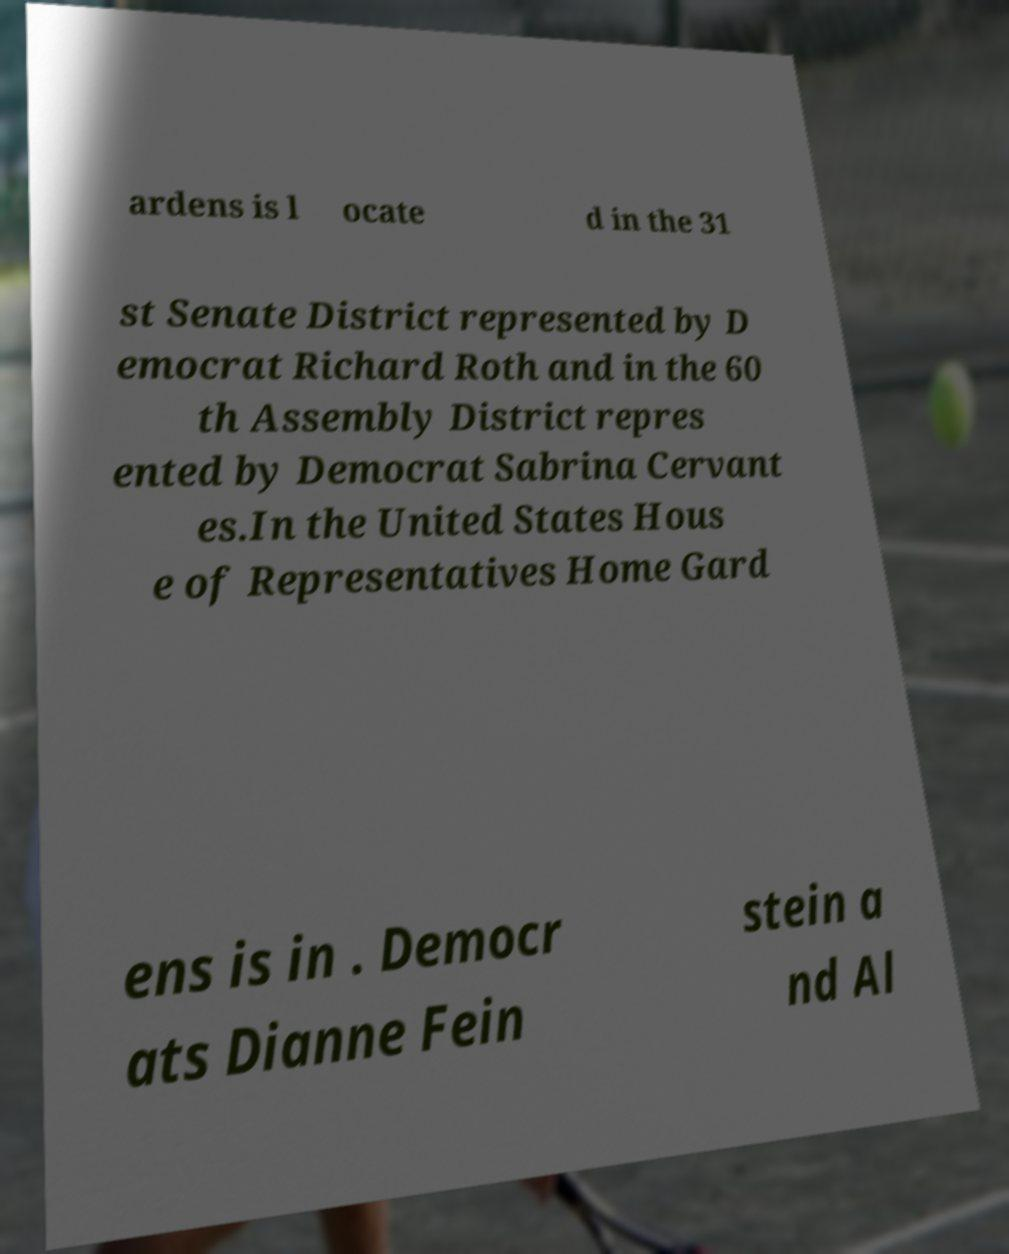Could you assist in decoding the text presented in this image and type it out clearly? ardens is l ocate d in the 31 st Senate District represented by D emocrat Richard Roth and in the 60 th Assembly District repres ented by Democrat Sabrina Cervant es.In the United States Hous e of Representatives Home Gard ens is in . Democr ats Dianne Fein stein a nd Al 